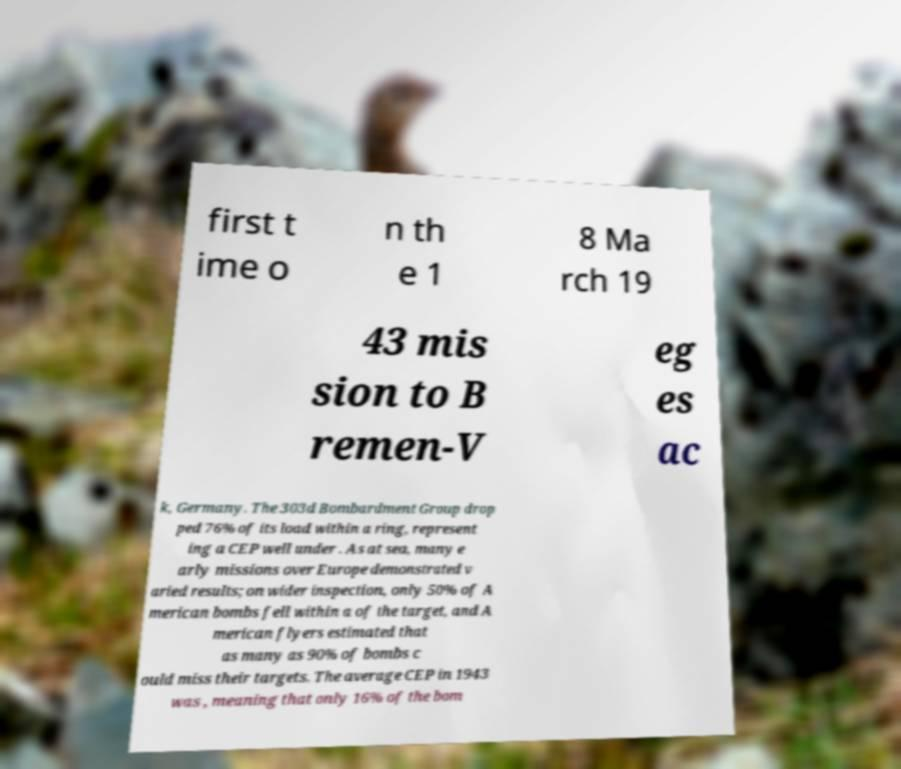Can you accurately transcribe the text from the provided image for me? first t ime o n th e 1 8 Ma rch 19 43 mis sion to B remen-V eg es ac k, Germany. The 303d Bombardment Group drop ped 76% of its load within a ring, represent ing a CEP well under . As at sea, many e arly missions over Europe demonstrated v aried results; on wider inspection, only 50% of A merican bombs fell within a of the target, and A merican flyers estimated that as many as 90% of bombs c ould miss their targets. The average CEP in 1943 was , meaning that only 16% of the bom 